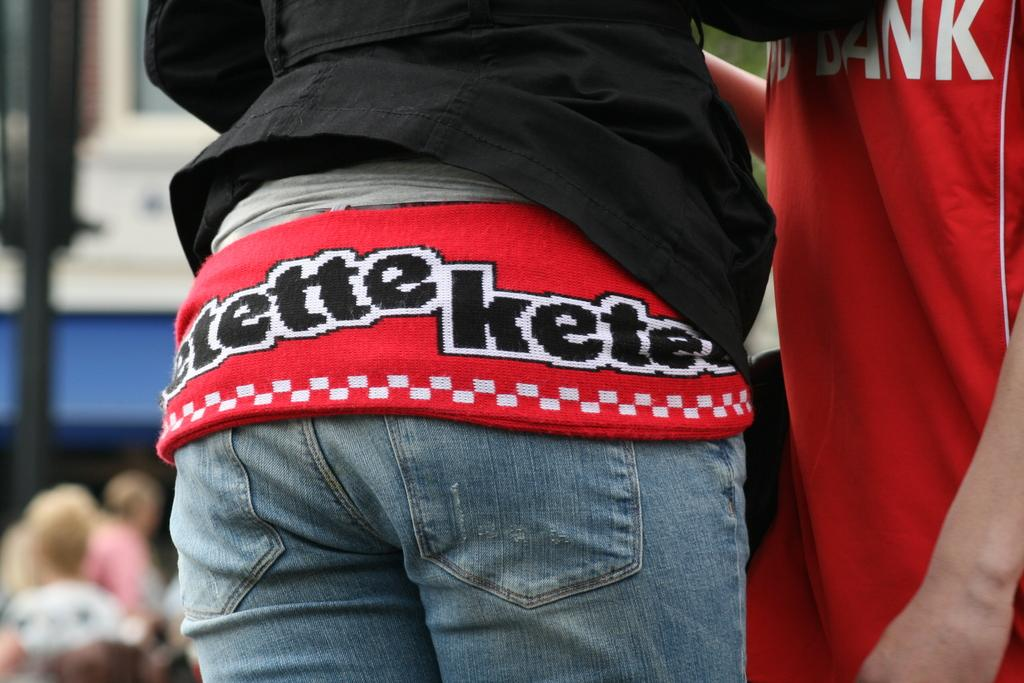Provide a one-sentence caption for the provided image. a person's jeans and their shirt that says etette kete on it. 